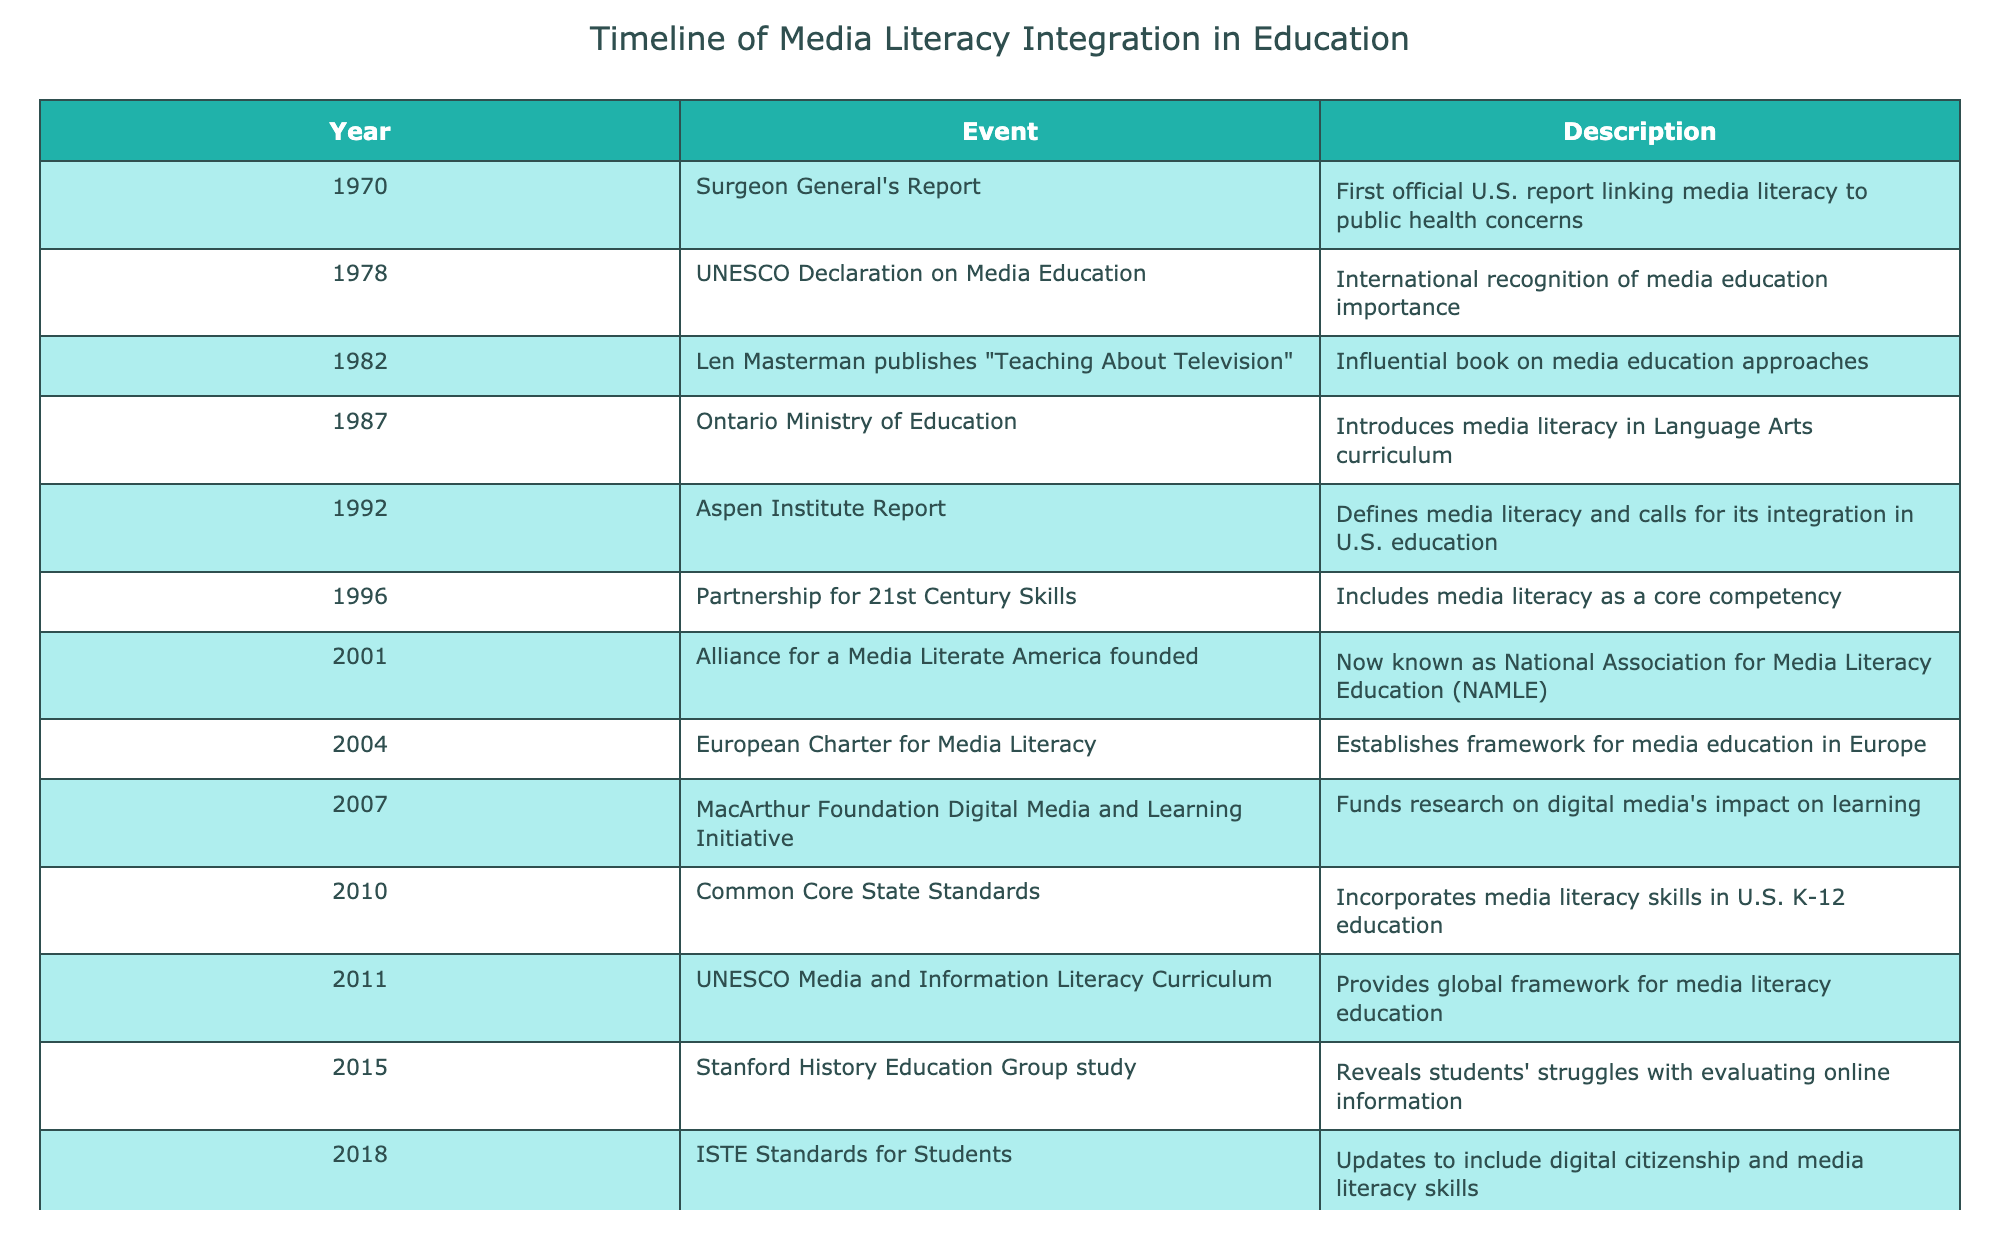What year did the Bulgarian Report on media literacy occur? The table does not list a "Bulgarian Report" on media literacy, thus we conclude it is not mentioned in the timeline entries.
Answer: No Which event marks the beginning of international recognition of media education? The table states that the UNESCO Declaration on Media Education in 1978 is the first event that internationally recognized the importance of media education.
Answer: 1978 What was the significant contribution of the Aspen Institute Report in 1992? According to the table, the Aspen Institute Report defined media literacy and emphasized the need for its integration into U.S. education, thus contributing to education policy.
Answer: Defined media literacy and called for its integration In what year was the Common Core State Standards established, and what did it incorporate? The table indicates that the Common Core State Standards were established in 2010 and that they incorporated media literacy skills into the K-12 education framework.
Answer: 2010, incorporated media literacy skills How many major milestones occurred between 1990 and 2010 that specifically focused on media literacy? From the years listed, the relevant milestones are the Aspen Institute Report in 1992, the Alliance for a Media Literate America founded in 2001, and the Common Core State Standards in 2010, totaling three major milestones focused on media literacy during this period.
Answer: 3 What are the two events that occurred in 2020 and their significance? The COVID-19 pandemic in 2020 accelerated the need for digital and media literacy due to remote learning challenges, highlighting the importance of these skills for students.
Answer: COVID-19 pandemic, accelerated need for digital literacy Was the introduction of media literacy in Ontario's education system an early event? The table records that the Ontario Ministry of Education introduced media literacy in Language Arts in 1987, which is relatively early compared to the timeline of overall media literacy events listed.
Answer: Yes What does the legislation proposed in 2022 aim to fund? The Digital Citizenship Education in Schools Act proposed in 2022 aims to fund K-12 media literacy programs, indicating a continuing effort to enhance media literacy in schools.
Answer: K-12 media literacy programs 